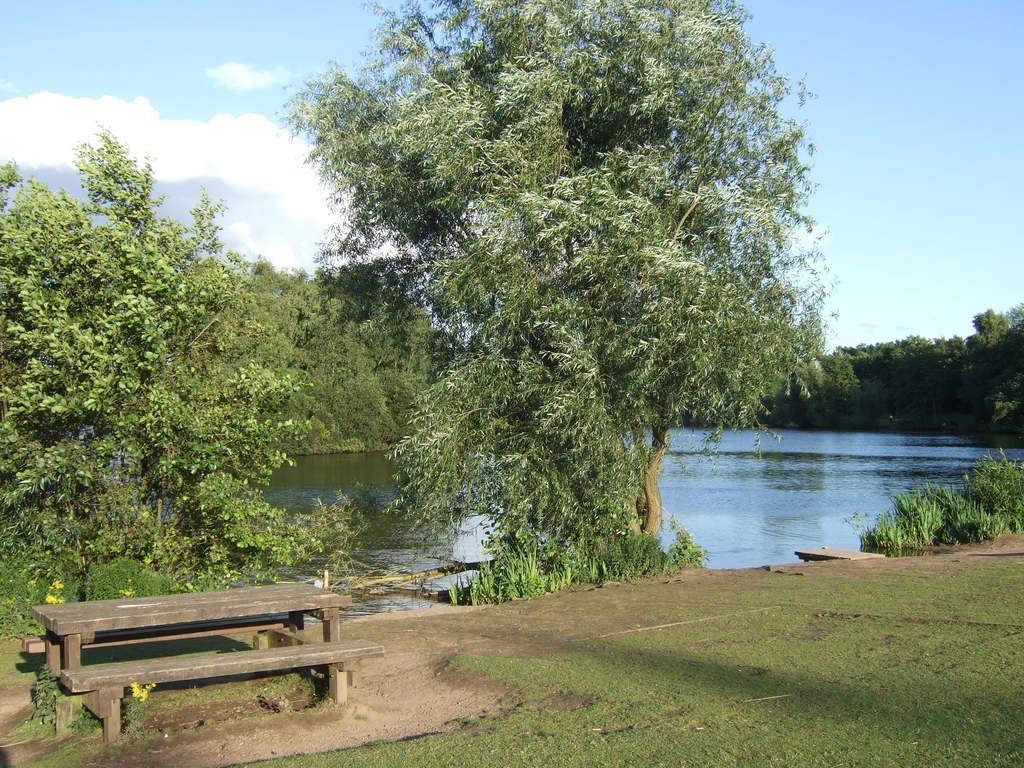How would you summarize this image in a sentence or two? In this image we can see a wooden table and bench on the bottom left side. Here we can see the green grass. Here we can see the lake and trees. Here we can see the clouds in the sky. 